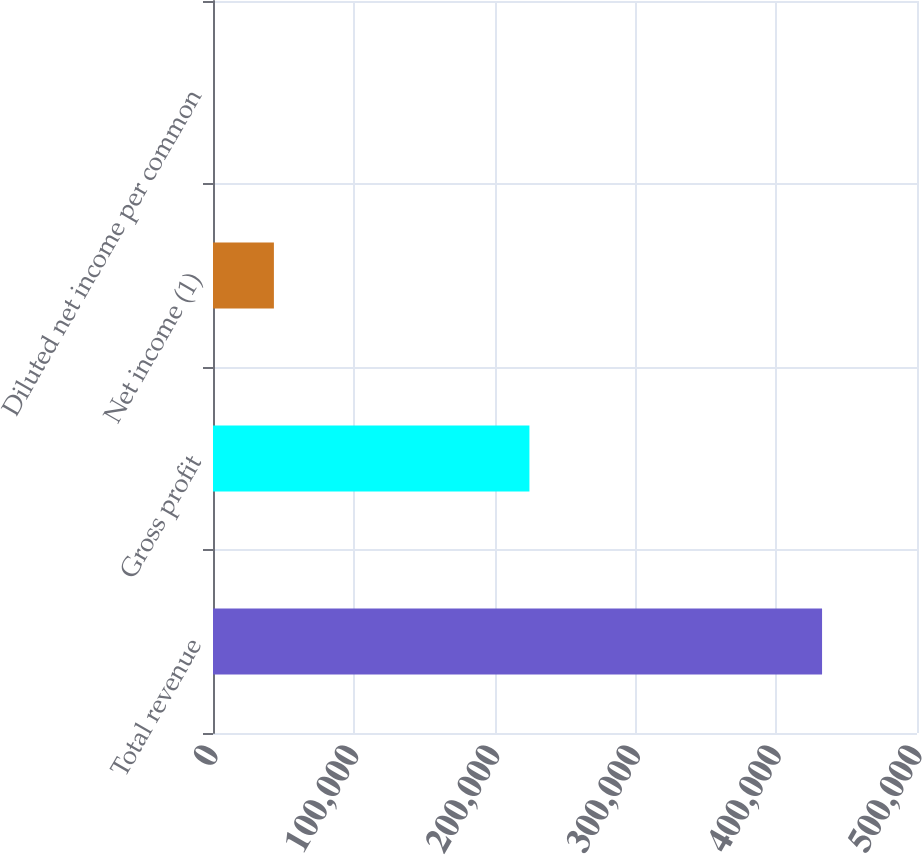Convert chart to OTSL. <chart><loc_0><loc_0><loc_500><loc_500><bar_chart><fcel>Total revenue<fcel>Gross profit<fcel>Net income (1)<fcel>Diluted net income per common<nl><fcel>432571<fcel>224734<fcel>43257.1<fcel>0.04<nl></chart> 